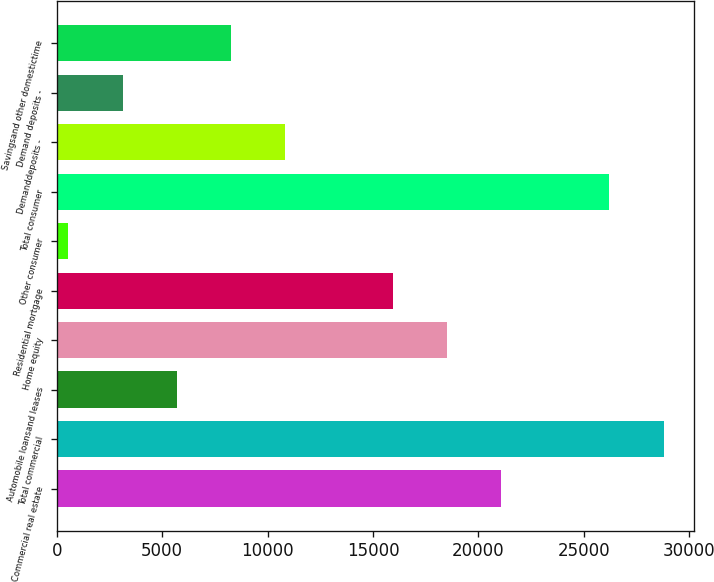Convert chart to OTSL. <chart><loc_0><loc_0><loc_500><loc_500><bar_chart><fcel>Commercial real estate<fcel>Total commercial<fcel>Automobile loansand leases<fcel>Home equity<fcel>Residential mortgage<fcel>Other consumer<fcel>Total consumer<fcel>Demanddeposits -<fcel>Demand deposits -<fcel>Savingsand other domestictime<nl><fcel>21090.3<fcel>28788<fcel>5694.9<fcel>18524.4<fcel>15958.5<fcel>529<fcel>26222.1<fcel>10826.7<fcel>3129<fcel>8260.8<nl></chart> 